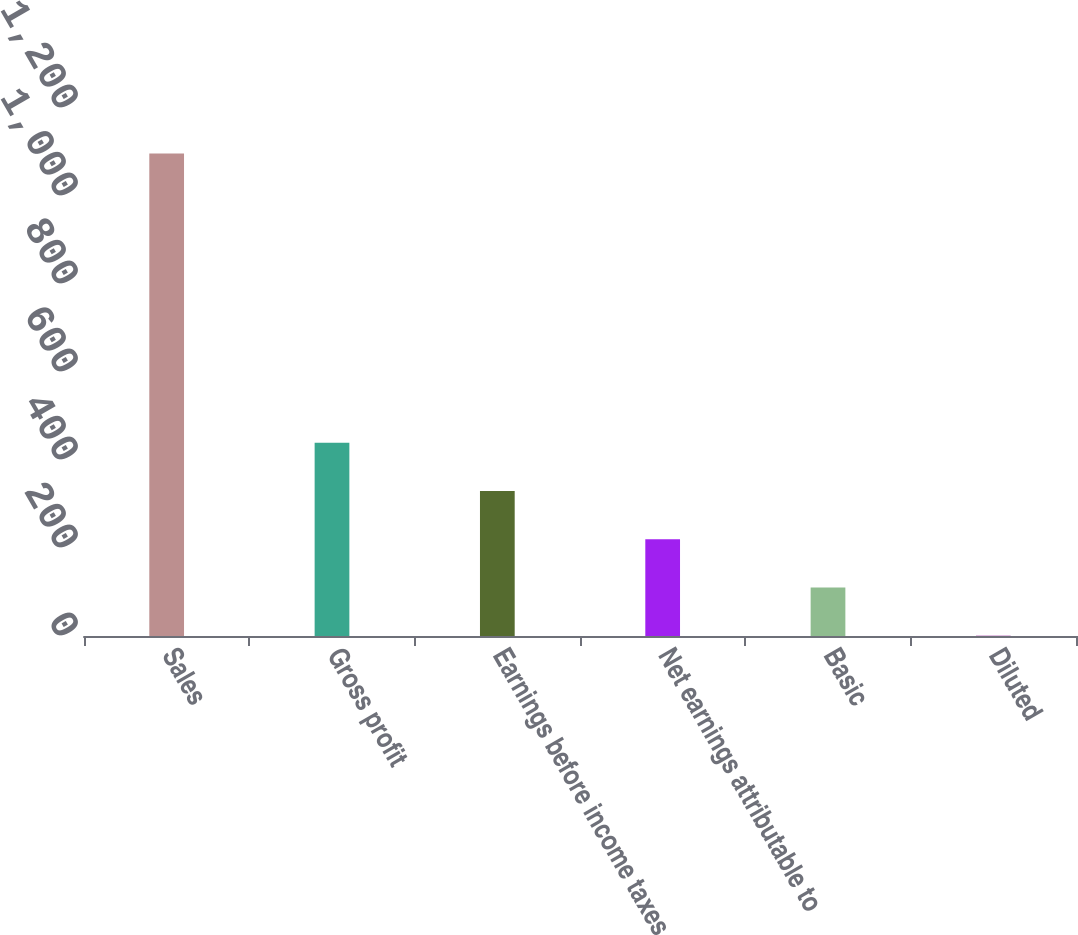Convert chart. <chart><loc_0><loc_0><loc_500><loc_500><bar_chart><fcel>Sales<fcel>Gross profit<fcel>Earnings before income taxes<fcel>Net earnings attributable to<fcel>Basic<fcel>Diluted<nl><fcel>1096.6<fcel>439.03<fcel>329.44<fcel>219.85<fcel>110.26<fcel>0.67<nl></chart> 